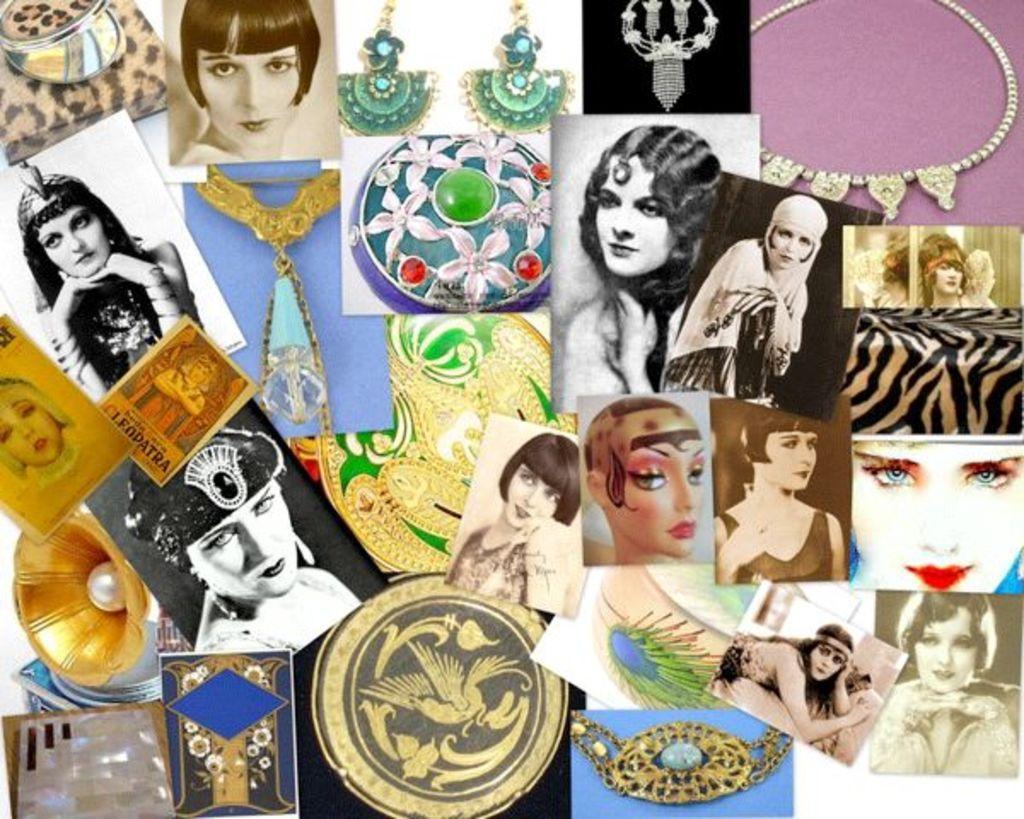Please provide a concise description of this image. In this image there is a board on that board there are photos of a woman and ornaments. 